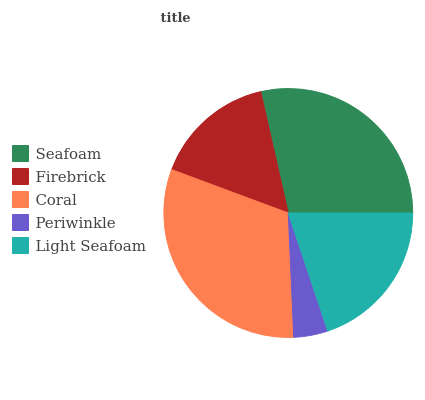Is Periwinkle the minimum?
Answer yes or no. Yes. Is Coral the maximum?
Answer yes or no. Yes. Is Firebrick the minimum?
Answer yes or no. No. Is Firebrick the maximum?
Answer yes or no. No. Is Seafoam greater than Firebrick?
Answer yes or no. Yes. Is Firebrick less than Seafoam?
Answer yes or no. Yes. Is Firebrick greater than Seafoam?
Answer yes or no. No. Is Seafoam less than Firebrick?
Answer yes or no. No. Is Light Seafoam the high median?
Answer yes or no. Yes. Is Light Seafoam the low median?
Answer yes or no. Yes. Is Seafoam the high median?
Answer yes or no. No. Is Periwinkle the low median?
Answer yes or no. No. 